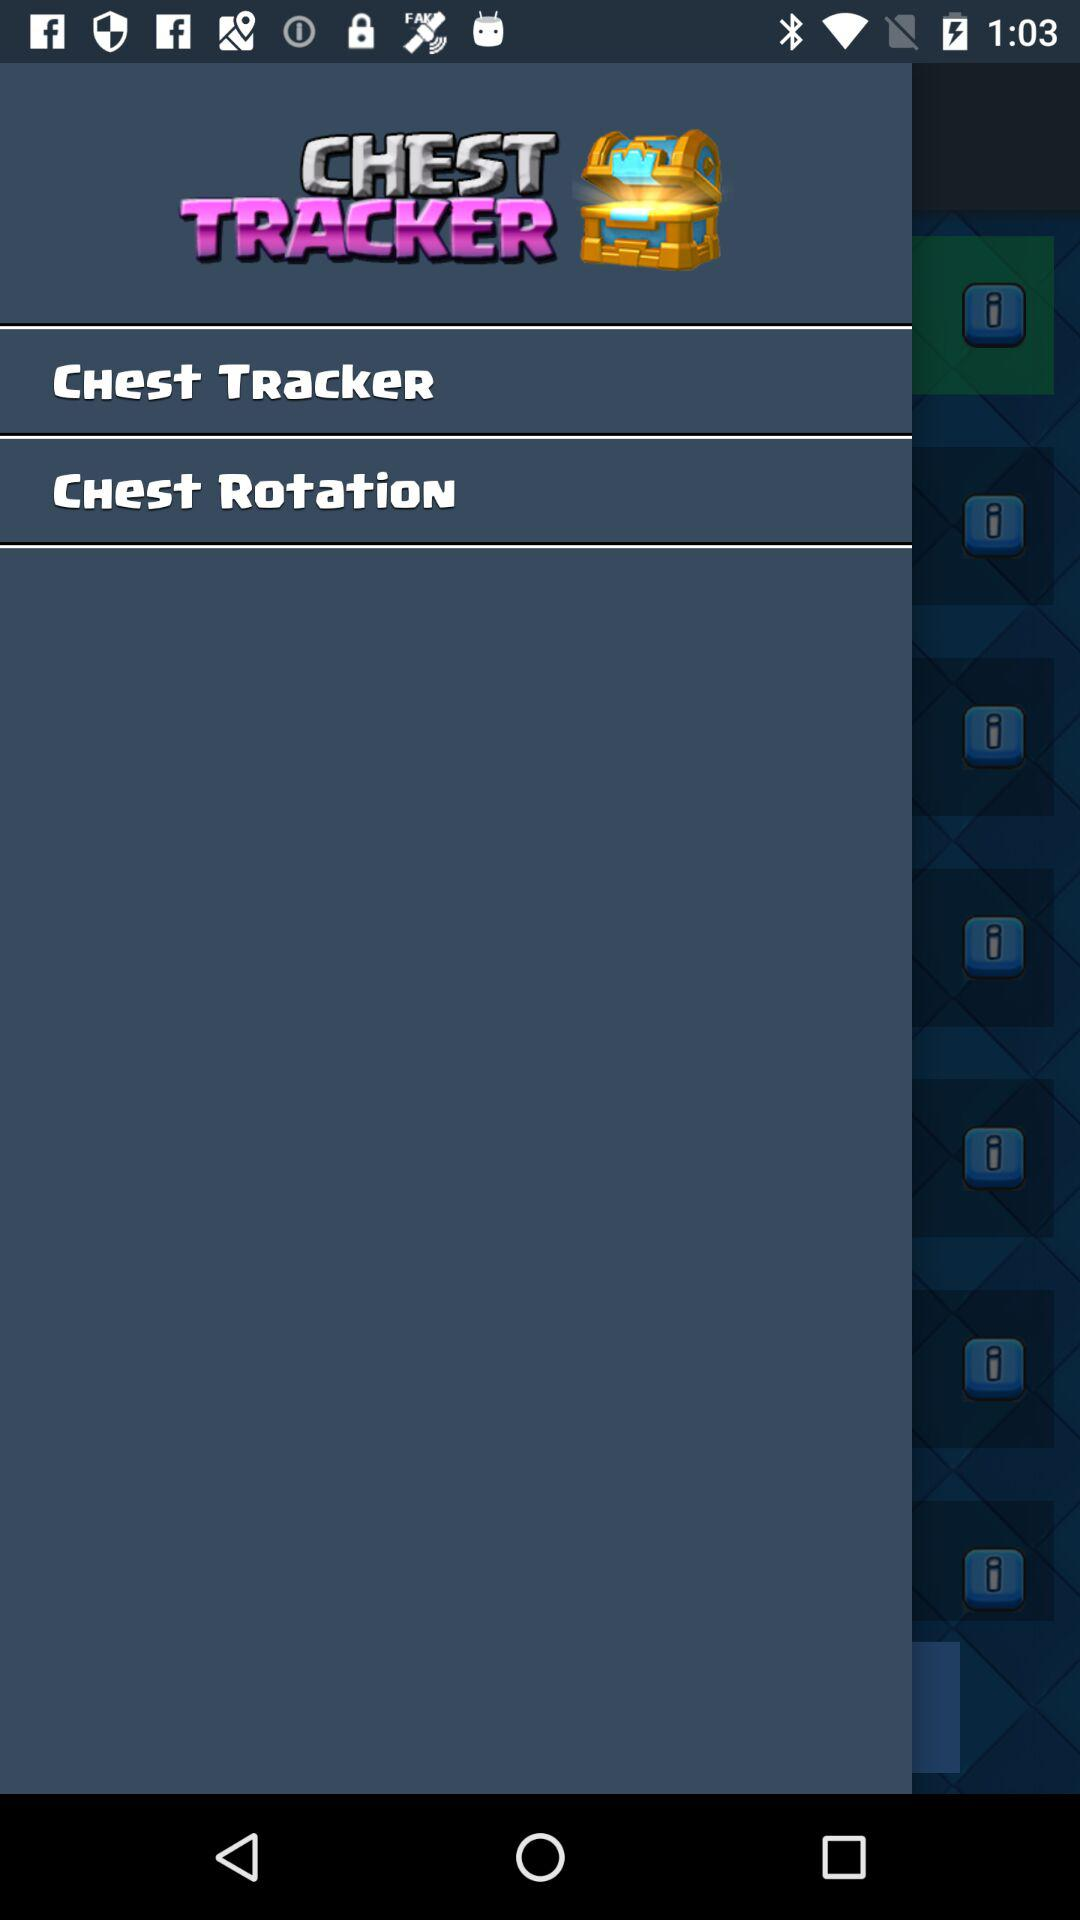Which is the selected chest?
When the provided information is insufficient, respond with <no answer>. <no answer> 